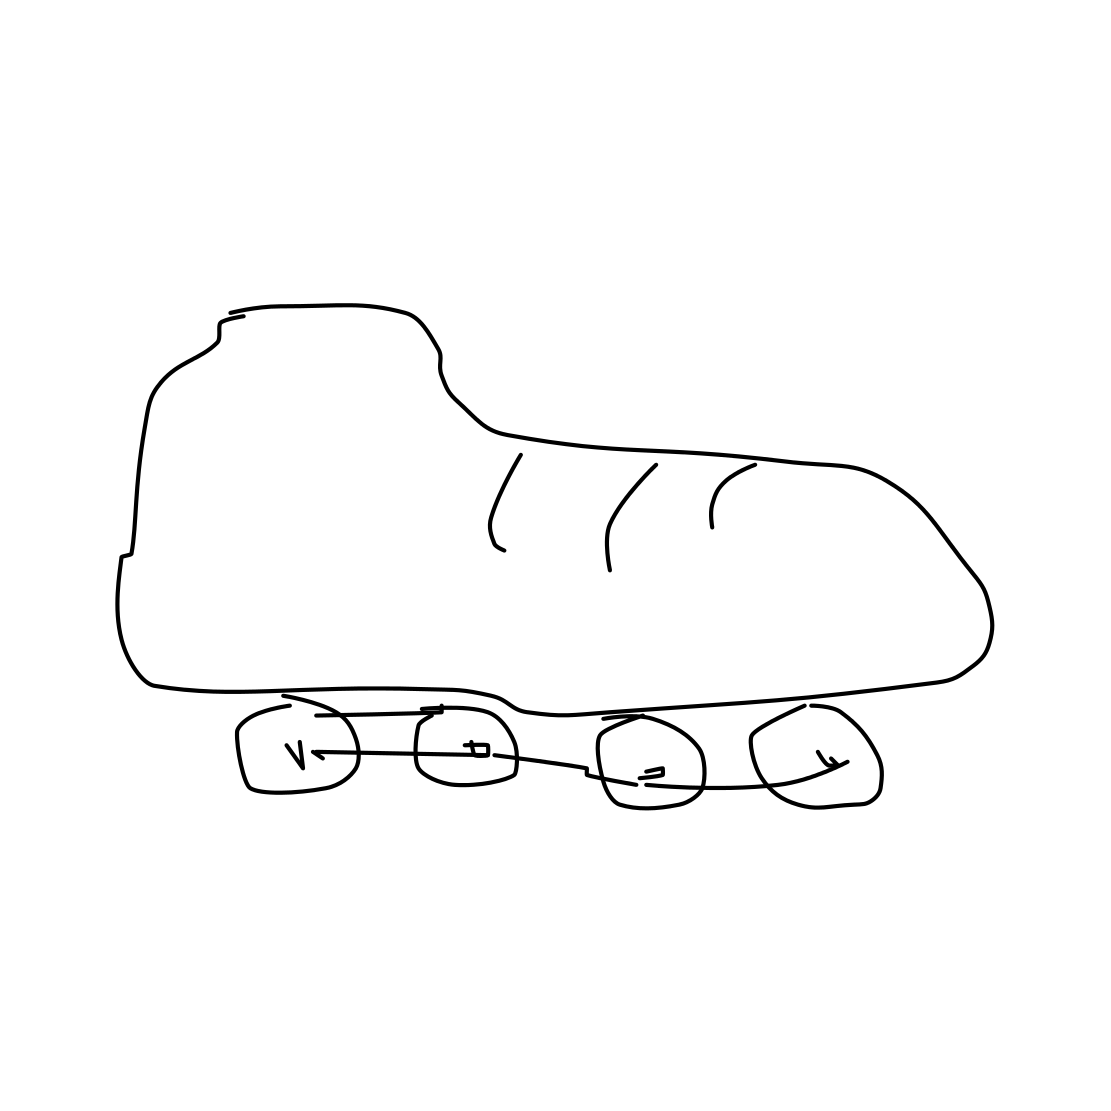Is there a sketchy rollerblades in the picture? Yes 